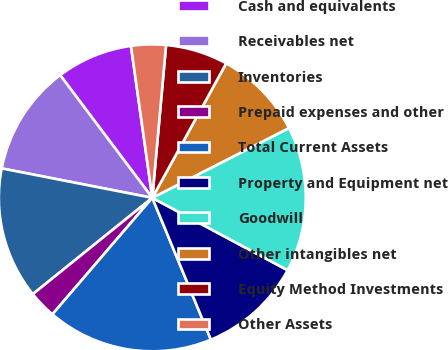Convert chart to OTSL. <chart><loc_0><loc_0><loc_500><loc_500><pie_chart><fcel>Cash and equivalents<fcel>Receivables net<fcel>Inventories<fcel>Prepaid expenses and other<fcel>Total Current Assets<fcel>Property and Equipment net<fcel>Goodwill<fcel>Other intangibles net<fcel>Equity Method Investments<fcel>Other Assets<nl><fcel>8.03%<fcel>11.68%<fcel>13.87%<fcel>2.92%<fcel>17.52%<fcel>10.95%<fcel>15.33%<fcel>9.49%<fcel>6.57%<fcel>3.65%<nl></chart> 